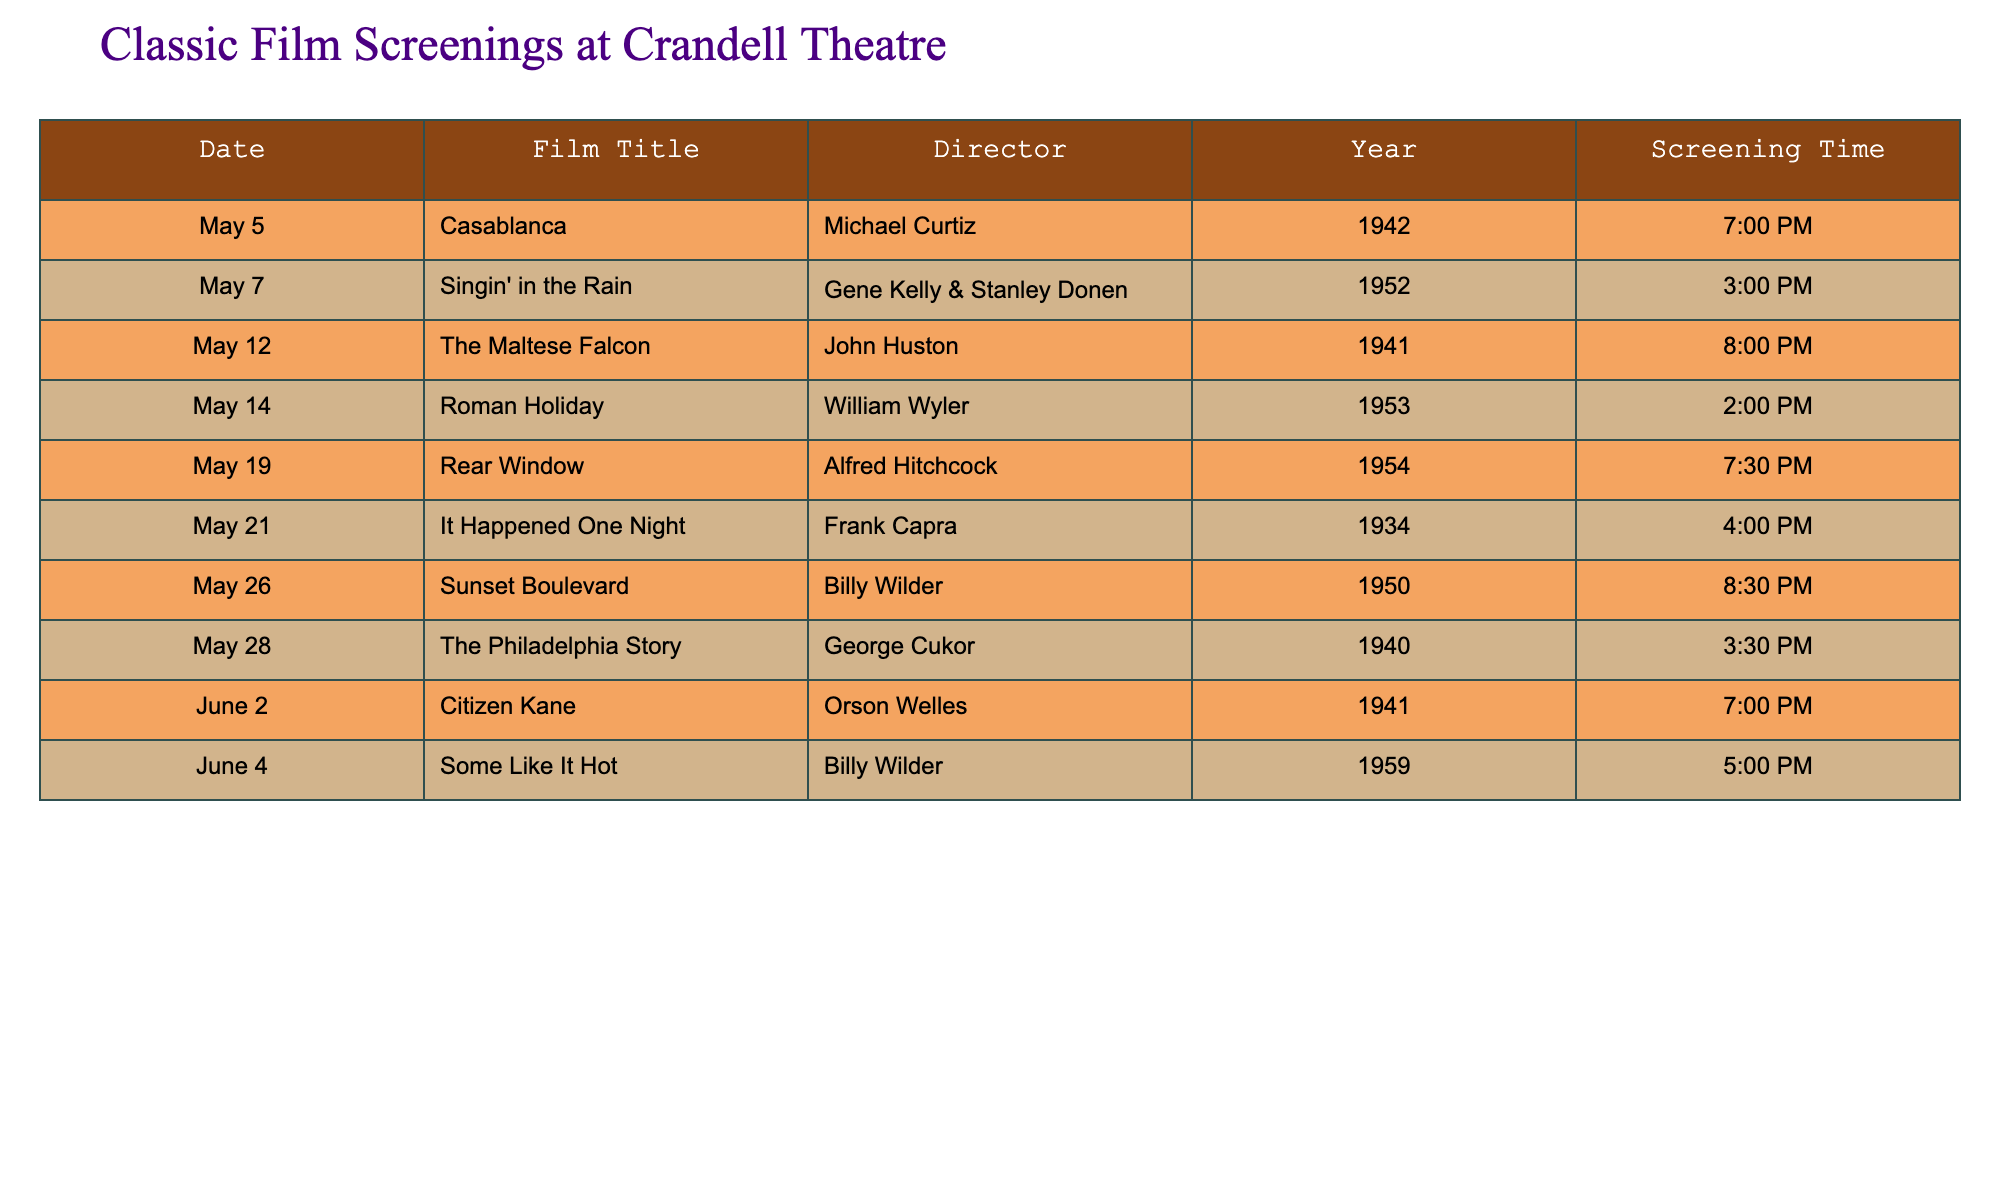What film is screened on May 7? The table shows that on May 7, the film scheduled is "Singin' in the Rain."
Answer: Singin' in the Rain Who directed "The Maltese Falcon"? According to the table, "The Maltese Falcon" was directed by John Huston.
Answer: John Huston What is the screening time for "Citizen Kane"? The screening time listed for "Citizen Kane" on June 2 is 7:00 PM.
Answer: 7:00 PM Which film is screened last in May? The last film screened in May is "The Philadelphia Story" on May 28, which shows at 3:30 PM.
Answer: The Philadelphia Story Is "Some Like It Hot" directed by Alfred Hitchcock? The table indicates that "Some Like It Hot" was directed by Billy Wilder, not Alfred Hitchcock.
Answer: No Which film has the latest screening time in the schedule? The table lists "Sunset Boulevard" on May 26 at 8:30 PM as the latest screening time.
Answer: Sunset Boulevard What is the difference in years between "Citizen Kane" and "It Happened One Night"? "Citizen Kane" was released in 1941, and "It Happened One Night" was released in 1934. The difference in years is 1941 - 1934 = 7 years.
Answer: 7 years How many films are screened on a Saturday in this schedule? By checking the specific dates, May 5 (Casablanca) and May 26 (Sunset Boulevard) fall on Saturdays, totaling 2 films.
Answer: 2 films What is the average screening time in the afternoon (before 6:00 PM)? The films screened before 6:00 PM are "Singin' in the Rain" (3:00 PM), "Roman Holiday" (2:00 PM), "It Happened One Night" (4:00 PM), and "The Philadelphia Story" (3:30 PM). Their total time is 3:00 + 2:00 + 4:00 + 3:30 = 12:30 PM. There are 4 screenings, so the average is 12:30 PM / 4 = 3:07 PM.
Answer: 3:07 PM What day has the most films scheduled? The data shows that May 5 and May 12 have just 1 film scheduled each, while May 19 has 1 film (Rear Window) and May 26 has 1 film (Sunset Boulevard). Each day has only 1 film scheduled, indicating no day has more than others.
Answer: No day has more films scheduled 